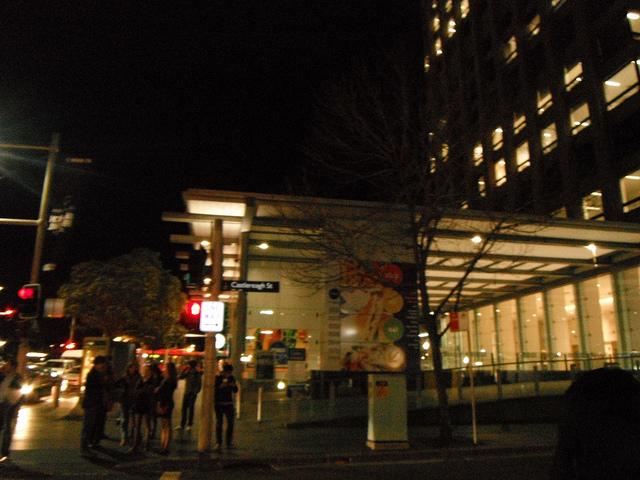Can you read what is written on the street sign?
Write a very short answer. No. Are the people waiting for a bus?
Answer briefly. Yes. How many people are there?
Be succinct. 7. What might visitors do in this plaza?
Keep it brief. Shop. Why are the lights on?
Quick response, please. Night. Where is the white awning?
Give a very brief answer. On building. What is the man doing?
Give a very brief answer. Walking. 